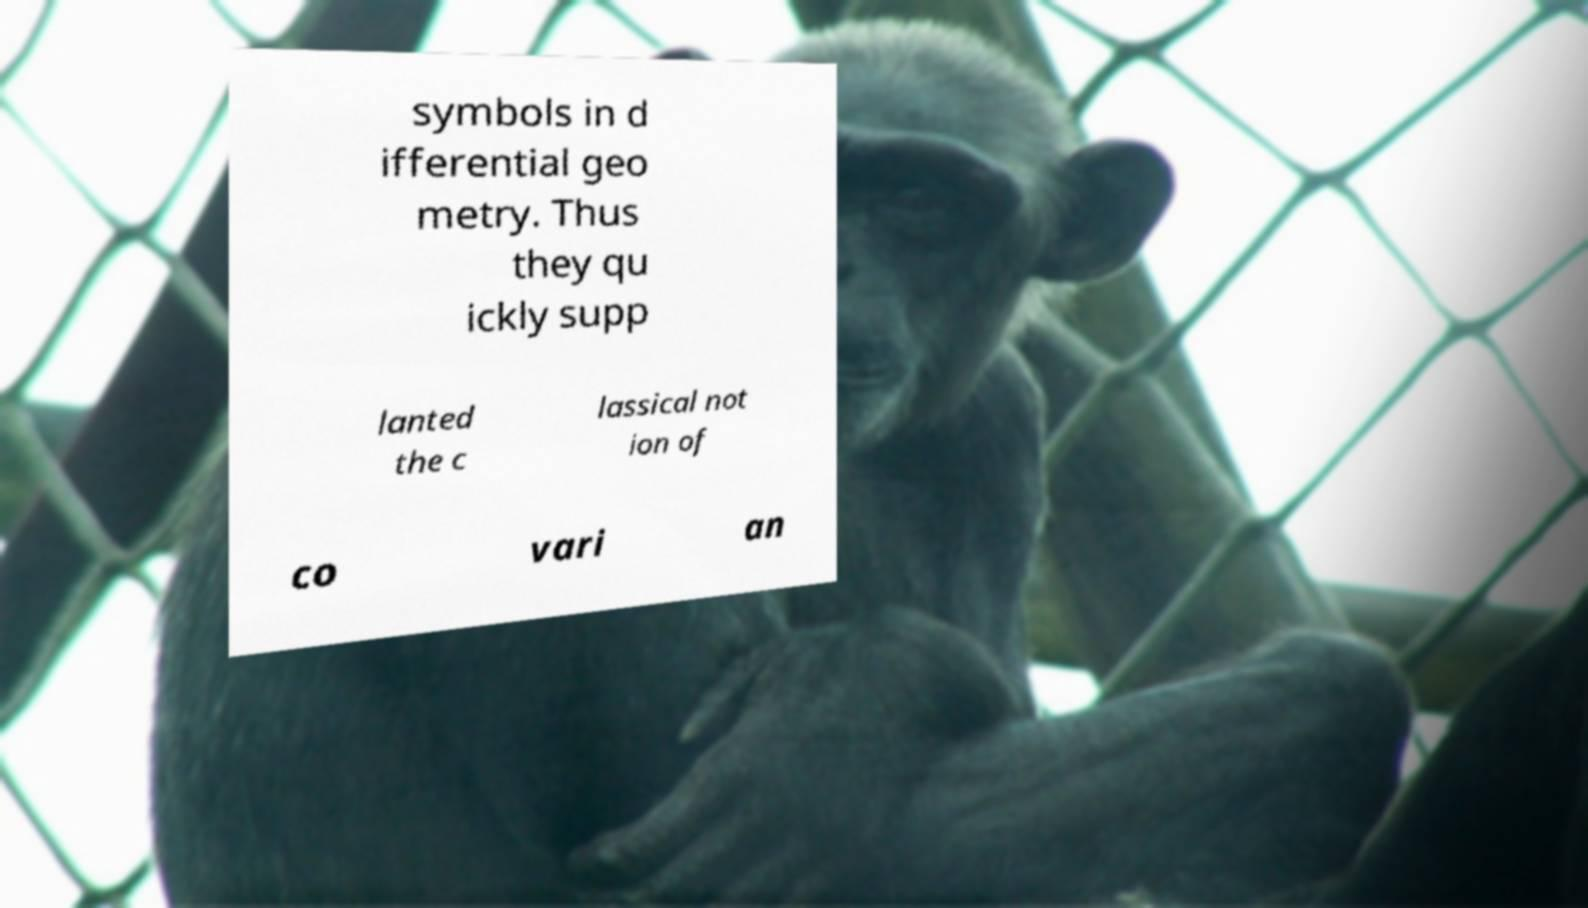Please identify and transcribe the text found in this image. symbols in d ifferential geo metry. Thus they qu ickly supp lanted the c lassical not ion of co vari an 